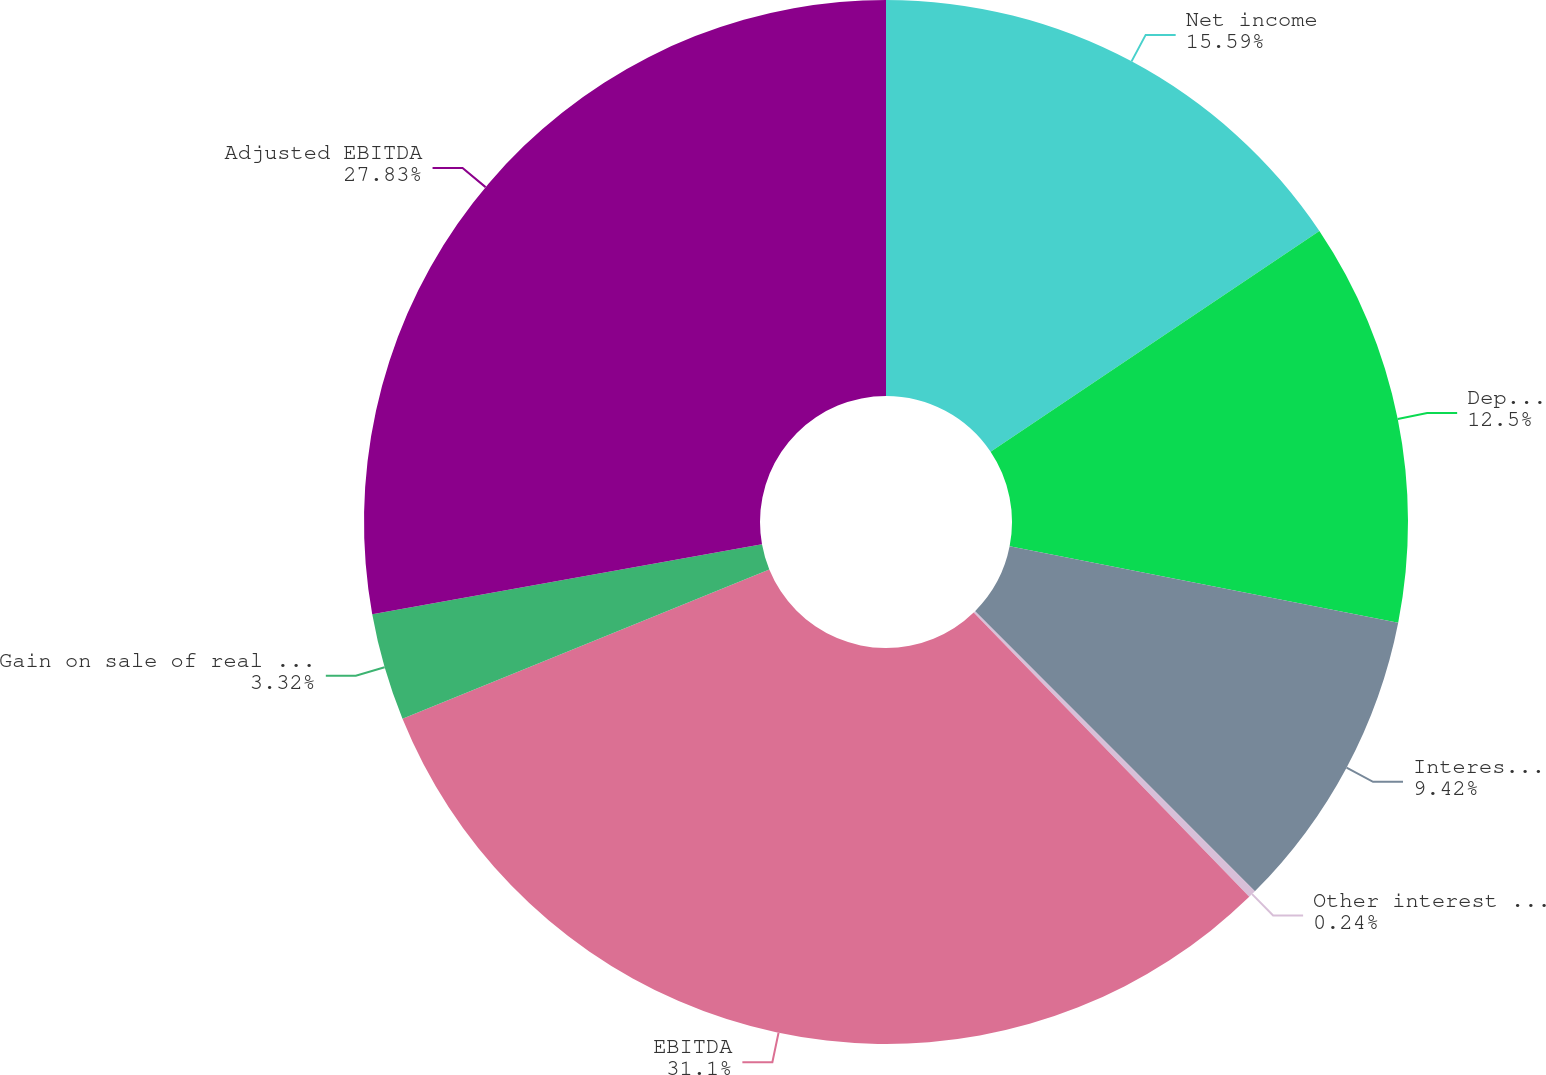<chart> <loc_0><loc_0><loc_500><loc_500><pie_chart><fcel>Net income<fcel>Depreciation and amortization<fcel>Interest expense<fcel>Other interest income<fcel>EBITDA<fcel>Gain on sale of real estate<fcel>Adjusted EBITDA<nl><fcel>15.59%<fcel>12.5%<fcel>9.42%<fcel>0.24%<fcel>31.1%<fcel>3.32%<fcel>27.83%<nl></chart> 